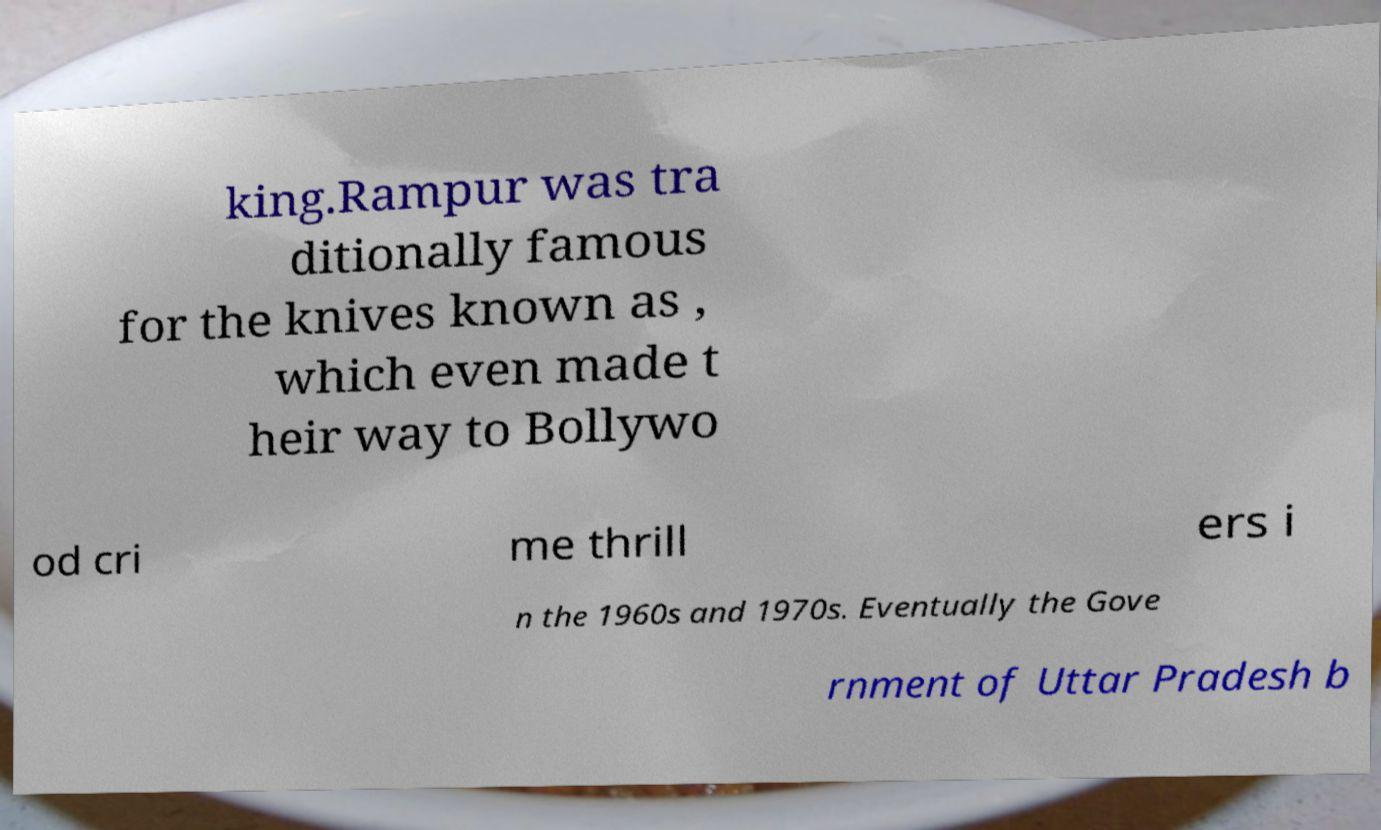For documentation purposes, I need the text within this image transcribed. Could you provide that? king.Rampur was tra ditionally famous for the knives known as , which even made t heir way to Bollywo od cri me thrill ers i n the 1960s and 1970s. Eventually the Gove rnment of Uttar Pradesh b 